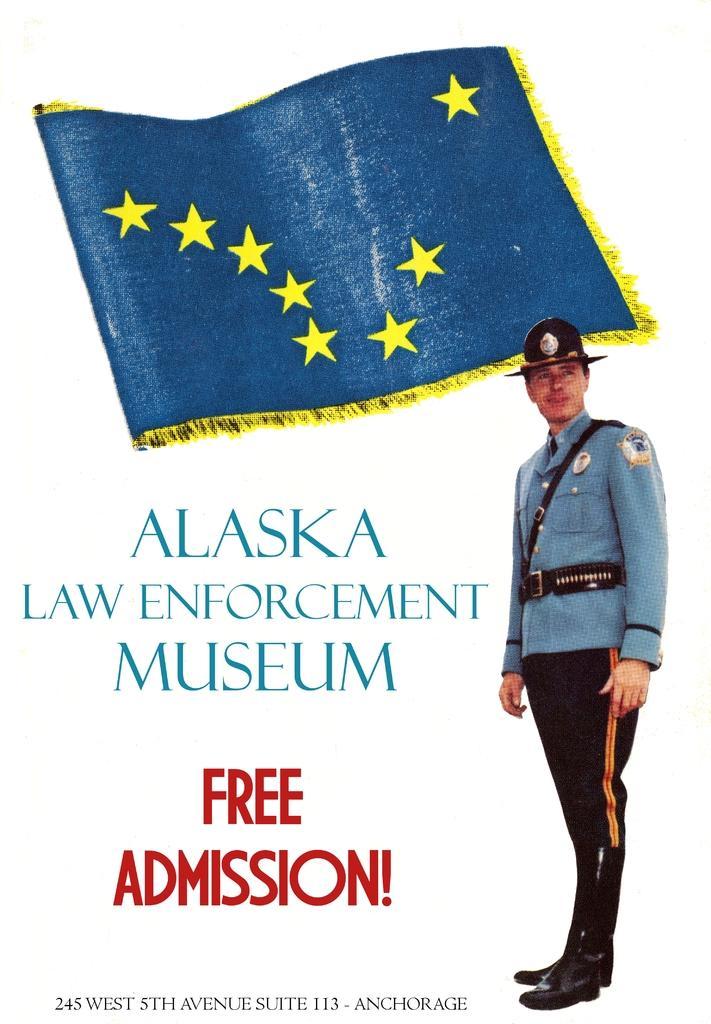Can you describe this image briefly? This picture shows a poster here we see a man standing with a cap on his head and we see a flag and text on it. 